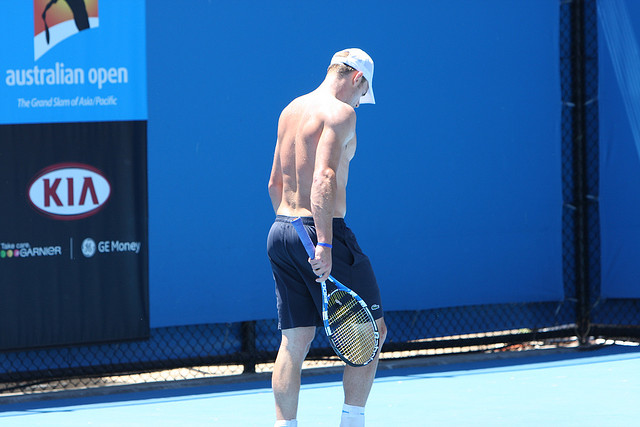Can you make up a casual conversation this tennis player might have with a friend? Sure! Here’s a casual conversation:

Friend: 'Hey, how's training going today?' 
Tennis Player: 'It's pretty intense, but you know how it is. Gotta keep pushing if you want to stay at the top.' 
Friend: 'Absolutely. Any big matches coming up?' 
Tennis Player: 'Yeah, the Australian Open is just around the corner. Just doing some fine-tuning on my serves right now.' 
Friend: 'You got this! Remember that killer backhand you nailed last season?' 
Tennis Player: 'Oh, definitely. Trying to make that a consistent part of my game. How about you? Any plans for the weekend?' 
Friend: 'Thinking of hitting the beach, maybe catch some waves. You should join if you get some free time.' 
Tennis Player: 'Sounds awesome! I’ll see if I can swing by after practice.' 